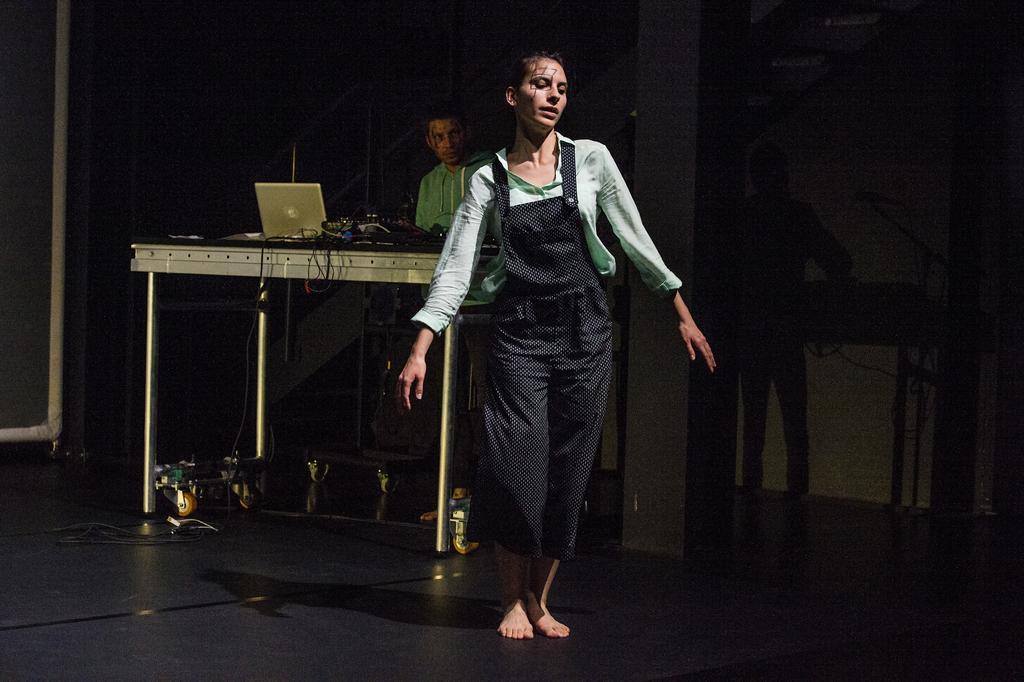Describe this image in one or two sentences. The girl in green shirt and black pant is dancing. Behind her, we see a man in green shirt is standing. In front of him, we see a table on which music player & recorder, cables and laptop are placed. In the background, it is black in color. This picture is clicked in the dark. 